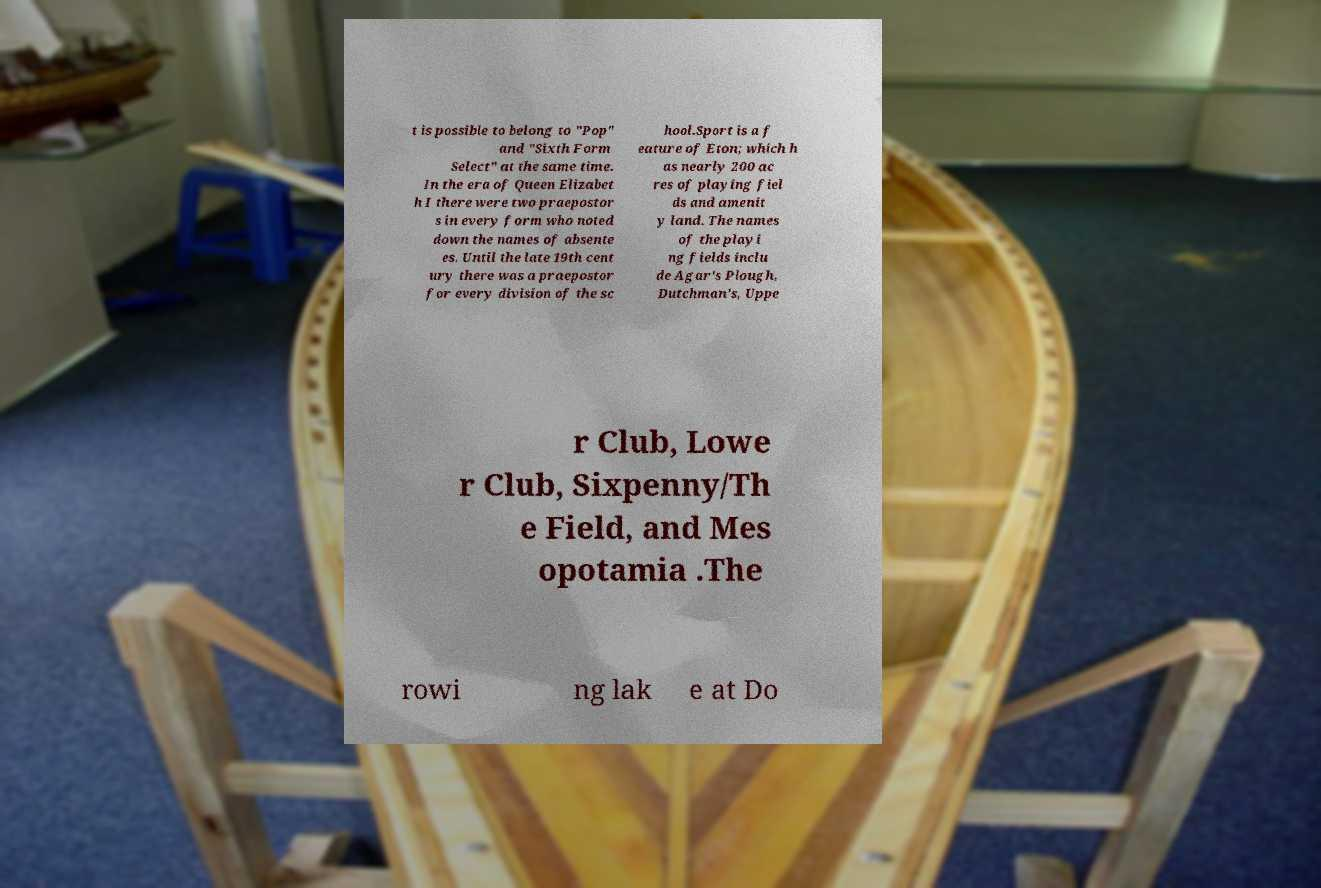Could you assist in decoding the text presented in this image and type it out clearly? t is possible to belong to "Pop" and "Sixth Form Select" at the same time. In the era of Queen Elizabet h I there were two praepostor s in every form who noted down the names of absente es. Until the late 19th cent ury there was a praepostor for every division of the sc hool.Sport is a f eature of Eton; which h as nearly 200 ac res of playing fiel ds and amenit y land. The names of the playi ng fields inclu de Agar's Plough, Dutchman's, Uppe r Club, Lowe r Club, Sixpenny/Th e Field, and Mes opotamia .The rowi ng lak e at Do 